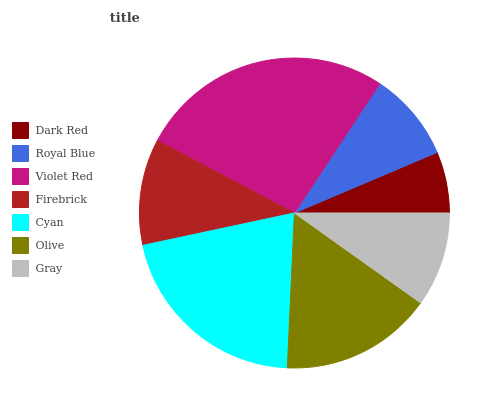Is Dark Red the minimum?
Answer yes or no. Yes. Is Violet Red the maximum?
Answer yes or no. Yes. Is Royal Blue the minimum?
Answer yes or no. No. Is Royal Blue the maximum?
Answer yes or no. No. Is Royal Blue greater than Dark Red?
Answer yes or no. Yes. Is Dark Red less than Royal Blue?
Answer yes or no. Yes. Is Dark Red greater than Royal Blue?
Answer yes or no. No. Is Royal Blue less than Dark Red?
Answer yes or no. No. Is Firebrick the high median?
Answer yes or no. Yes. Is Firebrick the low median?
Answer yes or no. Yes. Is Gray the high median?
Answer yes or no. No. Is Dark Red the low median?
Answer yes or no. No. 